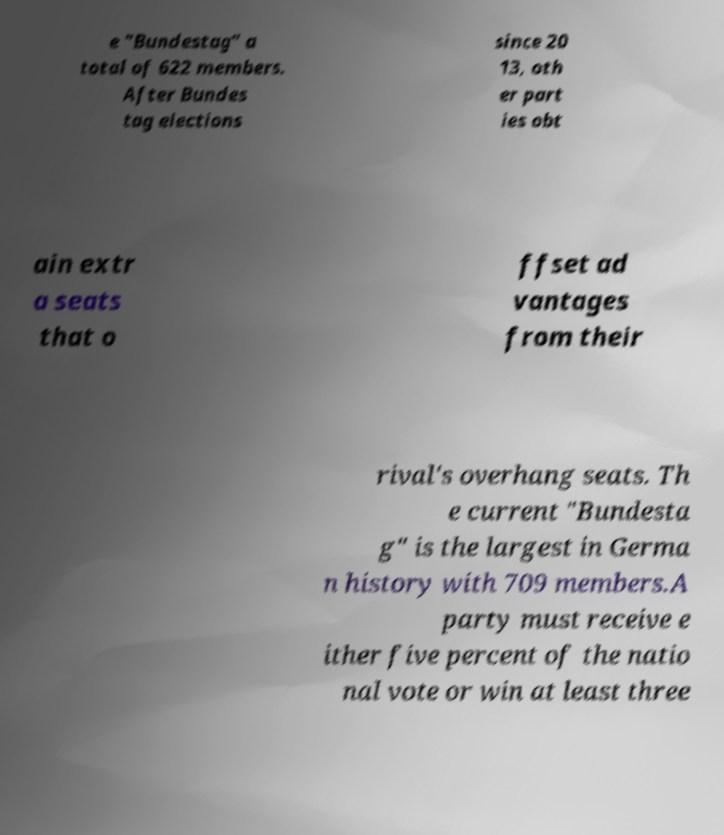What messages or text are displayed in this image? I need them in a readable, typed format. e "Bundestag" a total of 622 members. After Bundes tag elections since 20 13, oth er part ies obt ain extr a seats that o ffset ad vantages from their rival's overhang seats. Th e current "Bundesta g" is the largest in Germa n history with 709 members.A party must receive e ither five percent of the natio nal vote or win at least three 